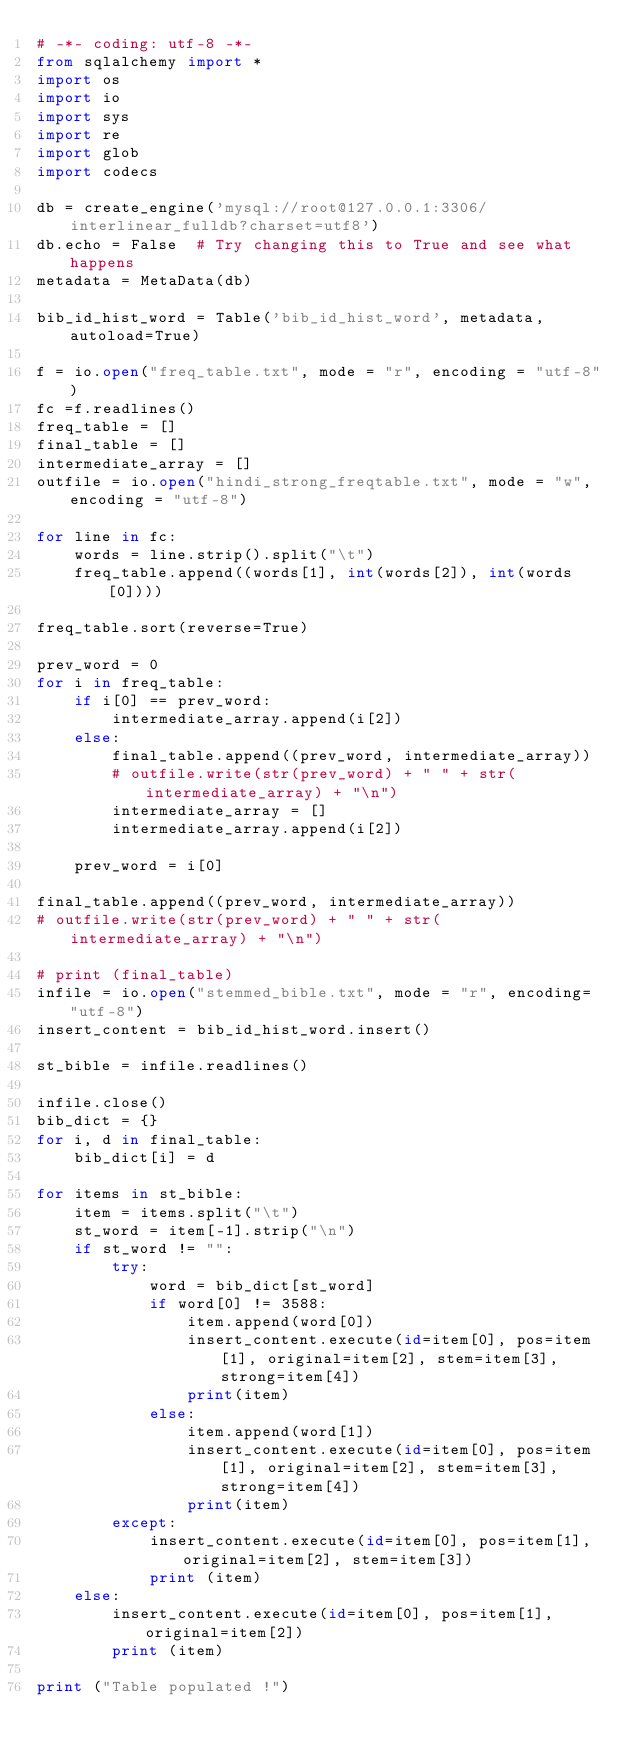Convert code to text. <code><loc_0><loc_0><loc_500><loc_500><_Python_># -*- coding: utf-8 -*-
from sqlalchemy import *
import os
import io
import sys
import re
import glob
import codecs

db = create_engine('mysql://root@127.0.0.1:3306/interlinear_fulldb?charset=utf8')
db.echo = False  # Try changing this to True and see what happens
metadata = MetaData(db)

bib_id_hist_word = Table('bib_id_hist_word', metadata, autoload=True)

f = io.open("freq_table.txt", mode = "r", encoding = "utf-8")
fc =f.readlines()
freq_table = []
final_table = []
intermediate_array = []
outfile = io.open("hindi_strong_freqtable.txt", mode = "w", encoding = "utf-8")

for line in fc:
	words = line.strip().split("\t")
	freq_table.append((words[1], int(words[2]), int(words[0]))) 

freq_table.sort(reverse=True)

prev_word = 0
for i in freq_table:
	if i[0] == prev_word:
		intermediate_array.append(i[2])
	else:
		final_table.append((prev_word, intermediate_array))
		# outfile.write(str(prev_word) + " " + str(intermediate_array) + "\n")
		intermediate_array = []
		intermediate_array.append(i[2])

	prev_word = i[0]

final_table.append((prev_word, intermediate_array))
# outfile.write(str(prev_word) + " " + str(intermediate_array) + "\n")

# print (final_table)
infile = io.open("stemmed_bible.txt", mode = "r", encoding= "utf-8")
insert_content = bib_id_hist_word.insert()

st_bible = infile.readlines()

infile.close()
bib_dict = {}
for i, d in final_table:
	bib_dict[i] = d

for items in st_bible:
	item = items.split("\t")
	st_word = item[-1].strip("\n")
	if st_word != "":
		try:
			word = bib_dict[st_word]
			if word[0] != 3588:
				item.append(word[0])
				insert_content.execute(id=item[0], pos=item[1], original=item[2], stem=item[3], strong=item[4])
				print(item)
			else:
				item.append(word[1])
				insert_content.execute(id=item[0], pos=item[1], original=item[2], stem=item[3], strong=item[4])
				print(item)
		except:
			insert_content.execute(id=item[0], pos=item[1], original=item[2], stem=item[3])
			print (item)
	else:
		insert_content.execute(id=item[0], pos=item[1], original=item[2])
		print (item)

print ("Table populated !")</code> 